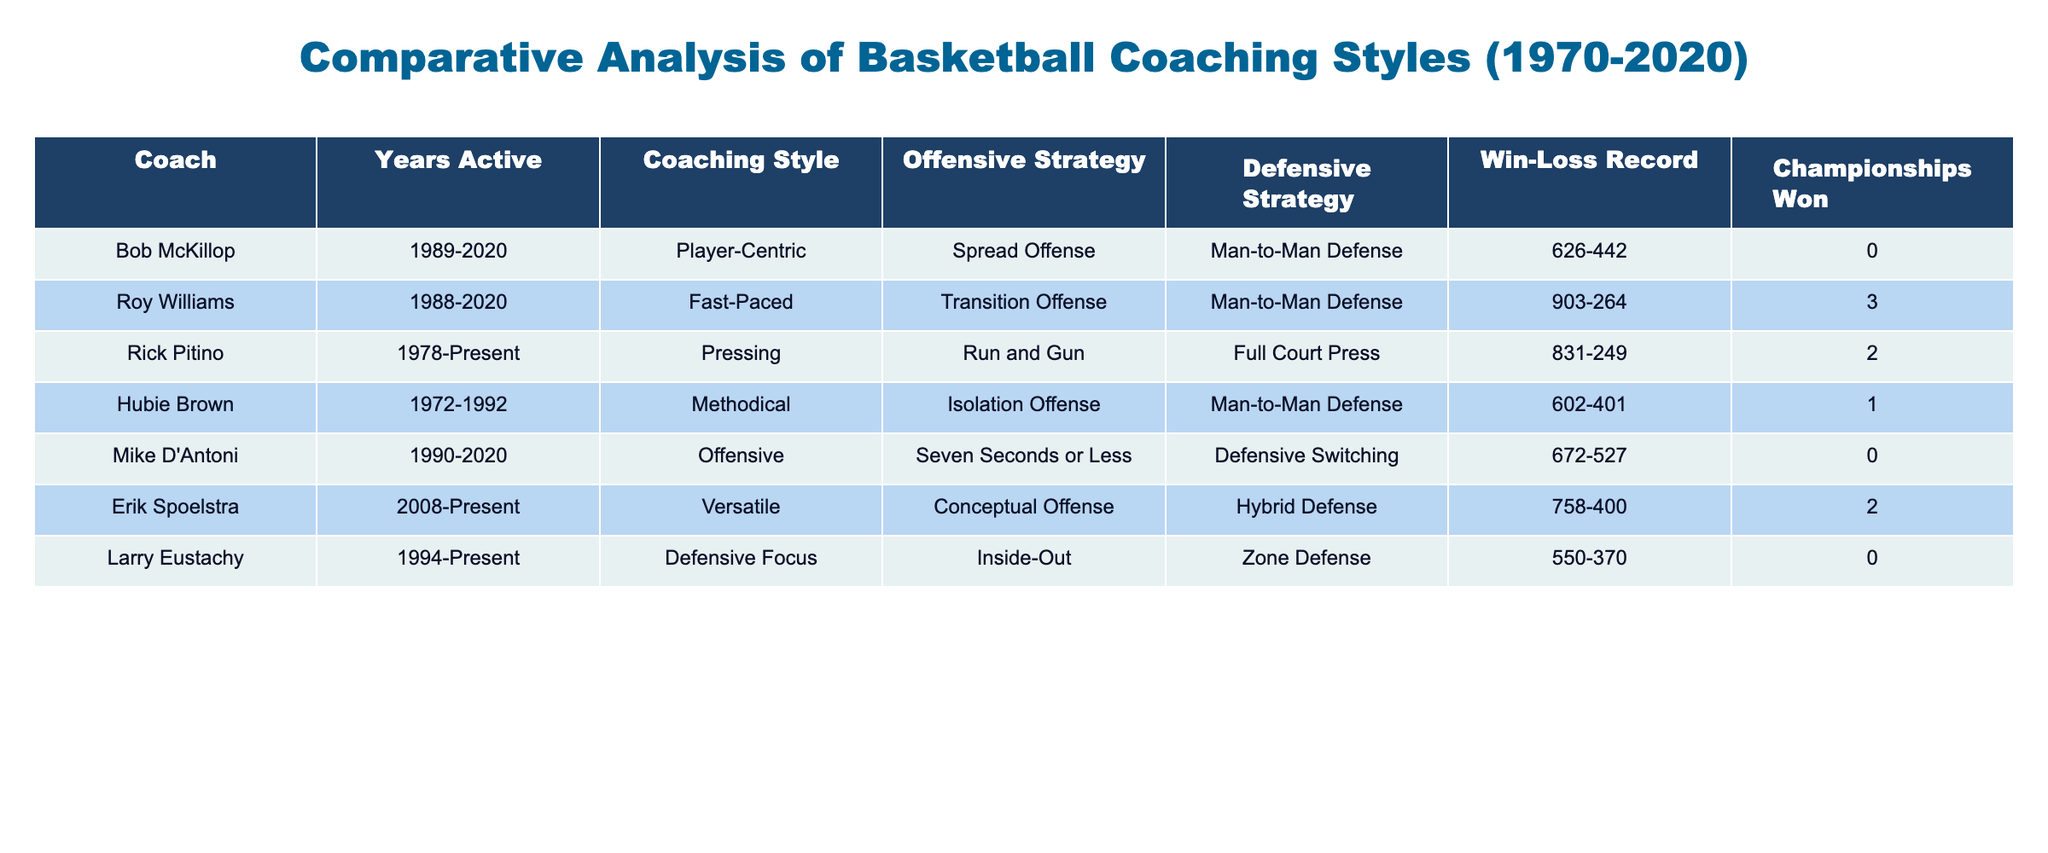What is the win-loss record of Bob McKillop? According to the table, Bob McKillop has a win-loss record of 626-442. This means he won 626 games and lost 442 games throughout his coaching career.
Answer: 626-442 Which coach has won the most championships? The table shows that Roy Williams has won the most championships, with a total of 3 championships.
Answer: 3 How many coaches have a player-centric coaching style? Based on the table, only one coach, Bob McKillop, has a player-centric coaching style, which is indicated in the 'Coaching Style' column.
Answer: 1 What is the average number of wins for all coaches listed? To calculate the average, sum the wins of each coach (626 + 903 + 831 + 602 + 672 + 758 + 550 = 4052), then divide by the number of coaches (7): 4052/7 ≈ 578.86. The average number of wins is approximately 579 when rounded.
Answer: 579 Is Erik Spoelstra's defensive strategy a hybrid defense? The table indicates that Erik Spoelstra's defensive strategy is indeed Hybrid Defense, confirming the statement.
Answer: Yes What is the difference in the number of wins between Roy Williams and Hubie Brown? Roy Williams has 903 wins while Hubie Brown has 602 wins, leading to a difference of 903 - 602 = 301 wins.
Answer: 301 How many coaches have a defensive focus style? According to the table, Larry Eustachy is the only coach with a defensive focus coaching style. Thus, there is only one coach with this style.
Answer: 1 Which coach has the highest win-loss ratio? To find the highest win-loss ratio, calculate each coach's ratio by dividing their wins by their losses (for example, Roy Williams: 903/264 ≈ 3.42). Comparing these ratios shows Rick Pitino has the highest ratio of approximately 3.34, but Roy Williams has the highest value at 3.42.
Answer: Roy Williams How many coaches have not won any championships? The table shows that Bob McKillop, Mike D'Antoni, and Larry Eustachy have not won any championships, totaling 3 coaches without titles.
Answer: 3 What offensive strategy is most common among the coaches listed? The table lists three distinct offensive strategies among coaches, but 'Man-to-Man Defense' is only associated with Hubie Brown, indicating that there is no common offensive strategy among these coaches. Thus, the answer is that no single offensive strategy is the most common since they all differ.
Answer: No common strategy 